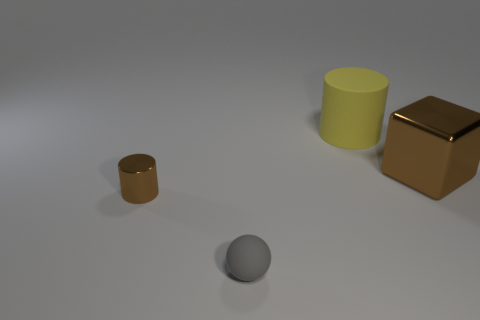Add 4 tiny cyan rubber cubes. How many objects exist? 8 Subtract all yellow cylinders. How many cylinders are left? 1 Subtract 0 green cylinders. How many objects are left? 4 Subtract all spheres. How many objects are left? 3 Subtract 2 cylinders. How many cylinders are left? 0 Subtract all brown cylinders. Subtract all brown spheres. How many cylinders are left? 1 Subtract all yellow cubes. How many brown cylinders are left? 1 Subtract all small shiny things. Subtract all metal things. How many objects are left? 1 Add 4 tiny shiny objects. How many tiny shiny objects are left? 5 Add 1 balls. How many balls exist? 2 